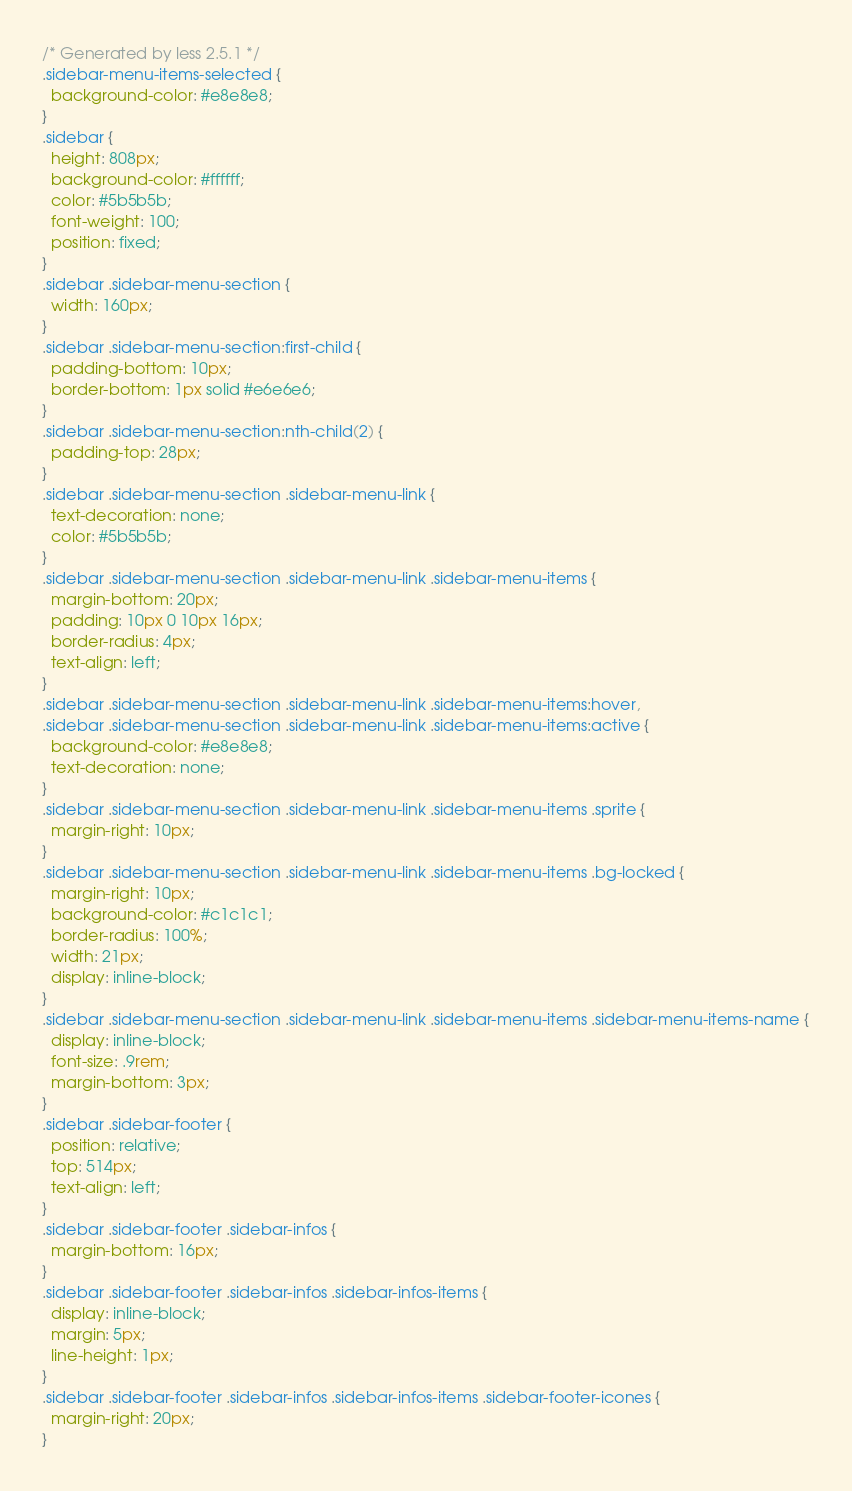Convert code to text. <code><loc_0><loc_0><loc_500><loc_500><_CSS_>/* Generated by less 2.5.1 */
.sidebar-menu-items-selected {
  background-color: #e8e8e8;
}
.sidebar {
  height: 808px;
  background-color: #ffffff;
  color: #5b5b5b;
  font-weight: 100;
  position: fixed;
}
.sidebar .sidebar-menu-section {
  width: 160px;
}
.sidebar .sidebar-menu-section:first-child {
  padding-bottom: 10px;
  border-bottom: 1px solid #e6e6e6;
}
.sidebar .sidebar-menu-section:nth-child(2) {
  padding-top: 28px;
}
.sidebar .sidebar-menu-section .sidebar-menu-link {
  text-decoration: none;
  color: #5b5b5b;
}
.sidebar .sidebar-menu-section .sidebar-menu-link .sidebar-menu-items {
  margin-bottom: 20px;
  padding: 10px 0 10px 16px;
  border-radius: 4px;
  text-align: left;
}
.sidebar .sidebar-menu-section .sidebar-menu-link .sidebar-menu-items:hover,
.sidebar .sidebar-menu-section .sidebar-menu-link .sidebar-menu-items:active {
  background-color: #e8e8e8;
  text-decoration: none;
}
.sidebar .sidebar-menu-section .sidebar-menu-link .sidebar-menu-items .sprite {
  margin-right: 10px;
}
.sidebar .sidebar-menu-section .sidebar-menu-link .sidebar-menu-items .bg-locked {
  margin-right: 10px;
  background-color: #c1c1c1;
  border-radius: 100%;
  width: 21px;
  display: inline-block;
}
.sidebar .sidebar-menu-section .sidebar-menu-link .sidebar-menu-items .sidebar-menu-items-name {
  display: inline-block;
  font-size: .9rem;
  margin-bottom: 3px;
}
.sidebar .sidebar-footer {
  position: relative;
  top: 514px;
  text-align: left;
}
.sidebar .sidebar-footer .sidebar-infos {
  margin-bottom: 16px;
}
.sidebar .sidebar-footer .sidebar-infos .sidebar-infos-items {
  display: inline-block;
  margin: 5px;
  line-height: 1px;
}
.sidebar .sidebar-footer .sidebar-infos .sidebar-infos-items .sidebar-footer-icones {
  margin-right: 20px;
}</code> 